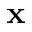<formula> <loc_0><loc_0><loc_500><loc_500>x</formula> 